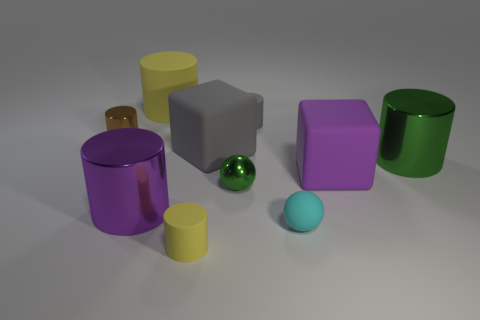How many objects in the image appear to have a reflective surface? There are two objects with reflective surfaces in the image: the tiny green metal object and the large purple cylinder. 